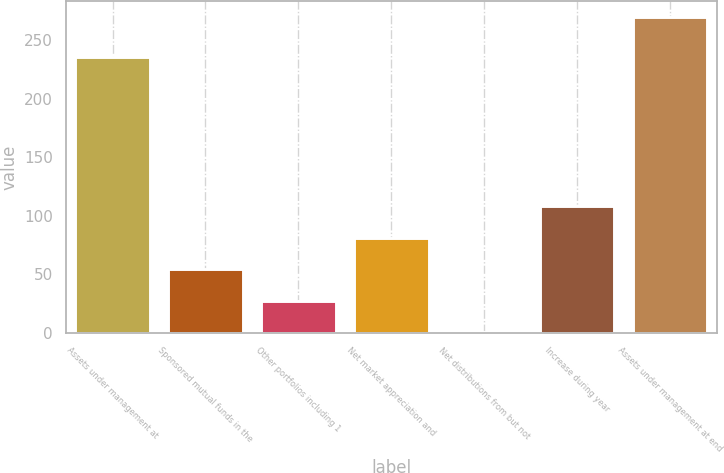Convert chart to OTSL. <chart><loc_0><loc_0><loc_500><loc_500><bar_chart><fcel>Assets under management at<fcel>Sponsored mutual funds in the<fcel>Other portfolios including 1<fcel>Net market appreciation and<fcel>Net distributions from but not<fcel>Increase during year<fcel>Assets under management at end<nl><fcel>235.2<fcel>54.3<fcel>27.4<fcel>81.2<fcel>0.5<fcel>108.1<fcel>269.5<nl></chart> 